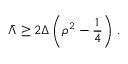<formula> <loc_0><loc_0><loc_500><loc_500>\bar { \Lambda } \geq 2 \Delta \left ( \rho ^ { 2 } - \frac { 1 } { 4 } \right ) \, .</formula> 